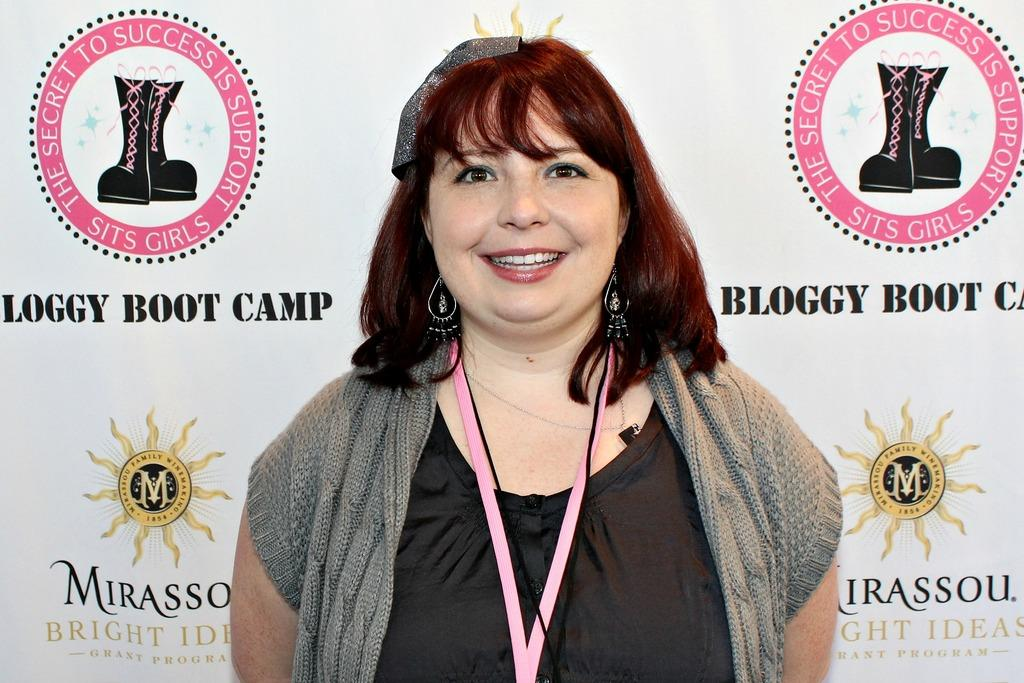What is: Who is the main subject in the image? There is a woman in the image. What is the woman doing in the image? The woman is standing and smiling. What can be seen in the background of the image? There is a board in the background of the image. What type of bells can be heard ringing in the image? There are no bells present in the image, and therefore no sound can be heard. 